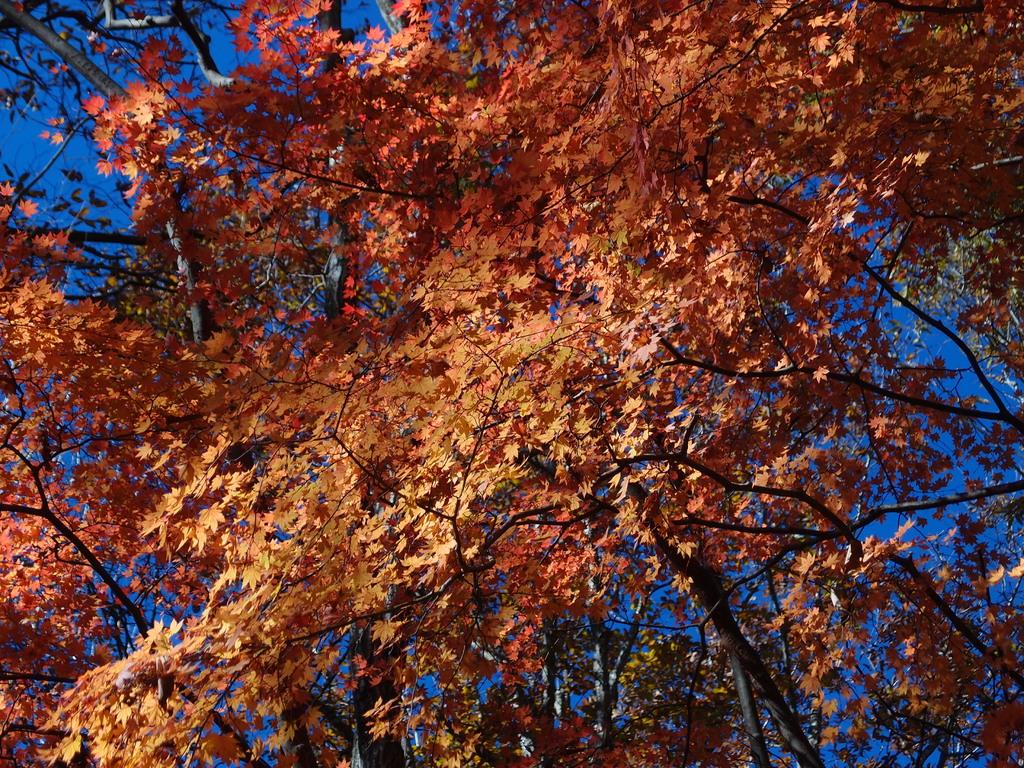What type of tree is present in the image? There is a maple leaf tree in the image. How many leaves can be seen on the tree? The tree has many leaves. What is visible in the background of the image? The sky is visible in the image. What color is the sky in the image? The sky is blue in color. What type of pear is growing on the tree in the image? There are no pears present in the image; it features a maple leaf tree with leaves. What type of treatment is being administered to the tree in the image? There is no treatment being administered to the tree in the image; it is a natural scene with a tree and leaves. 